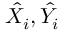<formula> <loc_0><loc_0><loc_500><loc_500>\hat { X _ { i } } , \hat { Y _ { i } }</formula> 